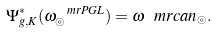Convert formula to latex. <formula><loc_0><loc_0><loc_500><loc_500>\Psi _ { g , K } ^ { * } ( \omega ^ { \ m r { P G L } } _ { \circledcirc } ) = \omega ^ { \ } m r { c a n } _ { \circledcirc } .</formula> 